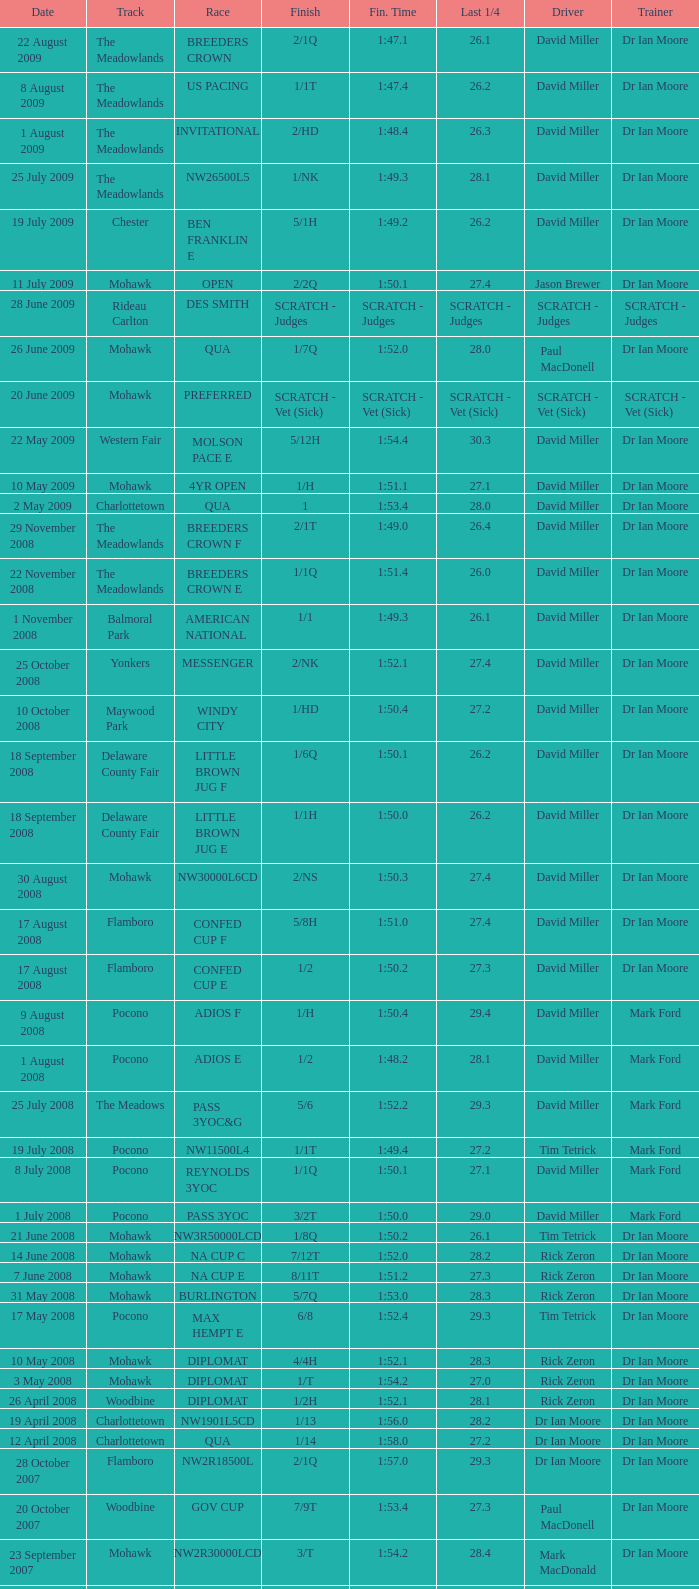What is the last 1/4 for the QUA race with a finishing time of 2:03.1? 29.2. 